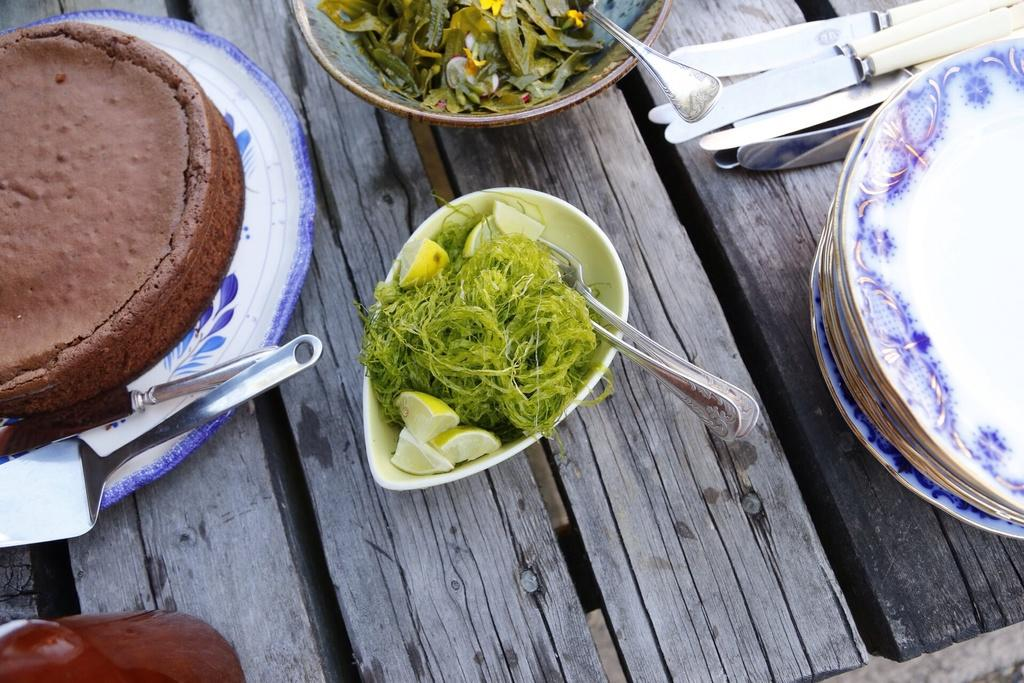What type of table is in the image? There is a wooden table in the image. What objects are on the table? There are plates, bowls, and knives on the table. What is in the plates and bowls? There is food in the plate and food in the bowl. Can you tell me how many kittens are playing with chalk on the table in the image? There are no kittens or chalk present on the table in the image. 